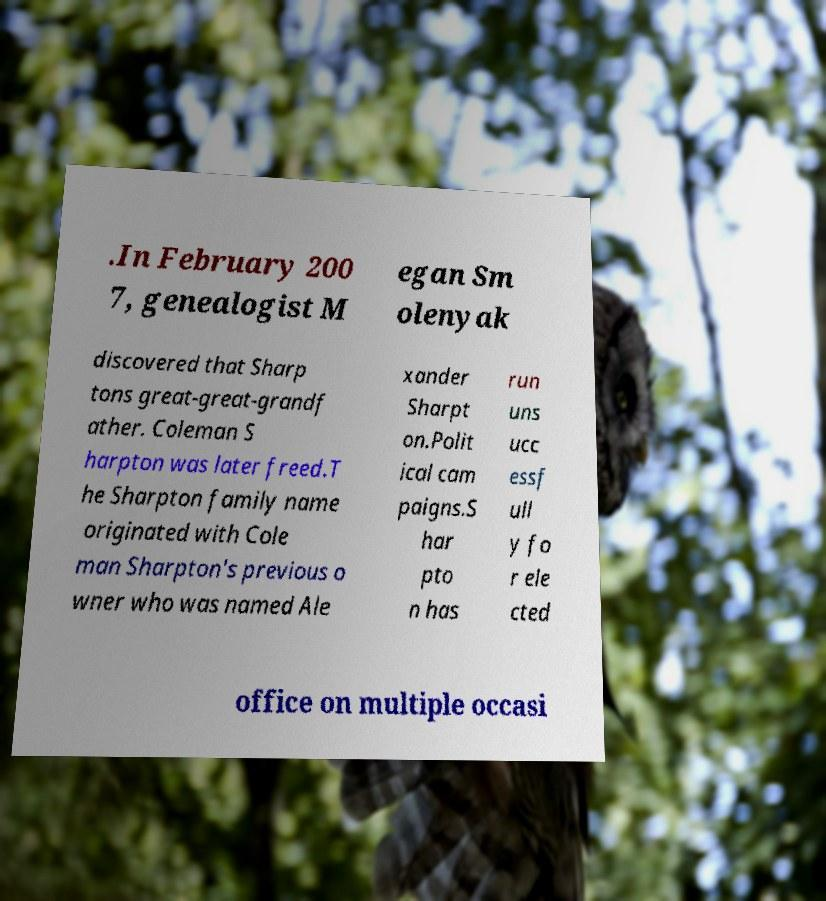I need the written content from this picture converted into text. Can you do that? .In February 200 7, genealogist M egan Sm olenyak discovered that Sharp tons great-great-grandf ather. Coleman S harpton was later freed.T he Sharpton family name originated with Cole man Sharpton's previous o wner who was named Ale xander Sharpt on.Polit ical cam paigns.S har pto n has run uns ucc essf ull y fo r ele cted office on multiple occasi 